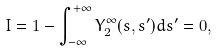<formula> <loc_0><loc_0><loc_500><loc_500>I = 1 - \int _ { - \infty } ^ { + \infty } Y _ { 2 } ^ { \infty } ( s , s ^ { \prime } ) d s ^ { \prime } = 0 ,</formula> 